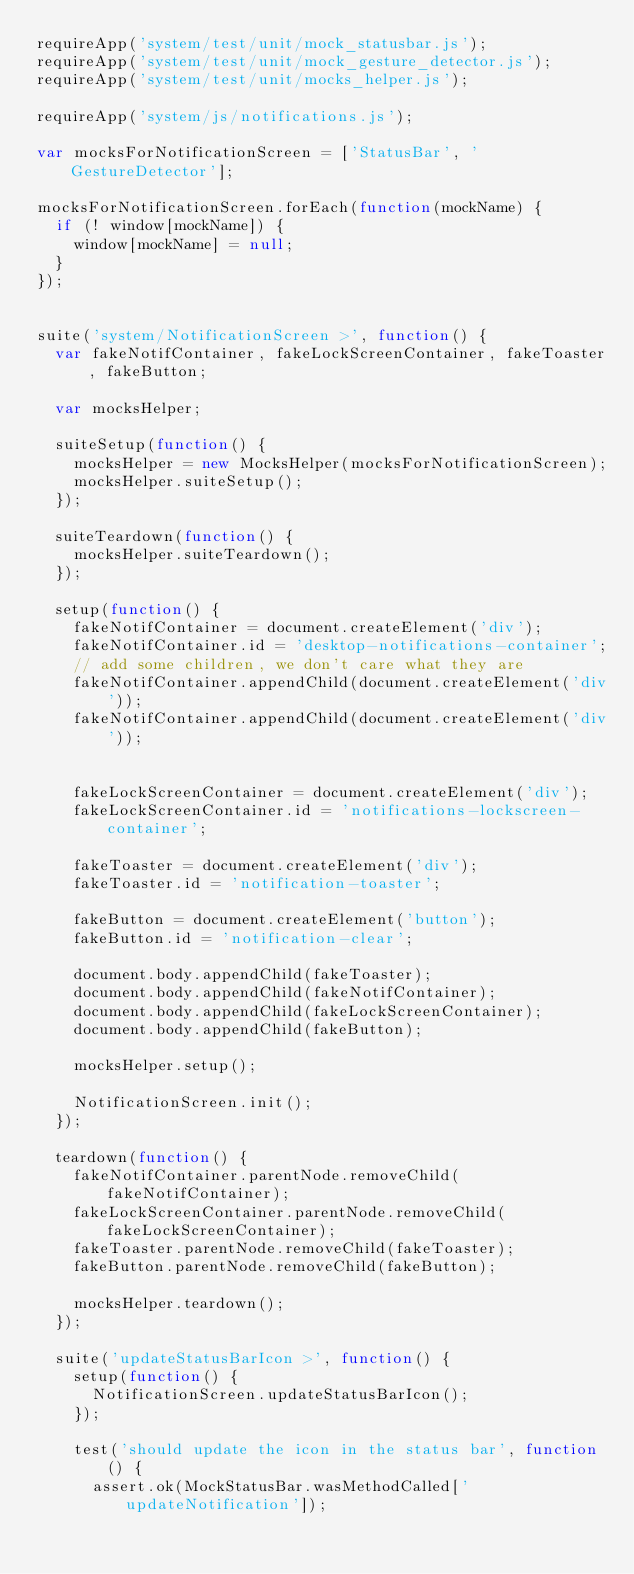<code> <loc_0><loc_0><loc_500><loc_500><_JavaScript_>requireApp('system/test/unit/mock_statusbar.js');
requireApp('system/test/unit/mock_gesture_detector.js');
requireApp('system/test/unit/mocks_helper.js');

requireApp('system/js/notifications.js');

var mocksForNotificationScreen = ['StatusBar', 'GestureDetector'];

mocksForNotificationScreen.forEach(function(mockName) {
  if (! window[mockName]) {
    window[mockName] = null;
  }
});


suite('system/NotificationScreen >', function() {
  var fakeNotifContainer, fakeLockScreenContainer, fakeToaster, fakeButton;

  var mocksHelper;

  suiteSetup(function() {
    mocksHelper = new MocksHelper(mocksForNotificationScreen);
    mocksHelper.suiteSetup();
  });

  suiteTeardown(function() {
    mocksHelper.suiteTeardown();
  });

  setup(function() {
    fakeNotifContainer = document.createElement('div');
    fakeNotifContainer.id = 'desktop-notifications-container';
    // add some children, we don't care what they are
    fakeNotifContainer.appendChild(document.createElement('div'));
    fakeNotifContainer.appendChild(document.createElement('div'));


    fakeLockScreenContainer = document.createElement('div');
    fakeLockScreenContainer.id = 'notifications-lockscreen-container';

    fakeToaster = document.createElement('div');
    fakeToaster.id = 'notification-toaster';

    fakeButton = document.createElement('button');
    fakeButton.id = 'notification-clear';

    document.body.appendChild(fakeToaster);
    document.body.appendChild(fakeNotifContainer);
    document.body.appendChild(fakeLockScreenContainer);
    document.body.appendChild(fakeButton);

    mocksHelper.setup();

    NotificationScreen.init();
  });

  teardown(function() {
    fakeNotifContainer.parentNode.removeChild(fakeNotifContainer);
    fakeLockScreenContainer.parentNode.removeChild(fakeLockScreenContainer);
    fakeToaster.parentNode.removeChild(fakeToaster);
    fakeButton.parentNode.removeChild(fakeButton);

    mocksHelper.teardown();
  });

  suite('updateStatusBarIcon >', function() {
    setup(function() {
      NotificationScreen.updateStatusBarIcon();
    });

    test('should update the icon in the status bar', function() {
      assert.ok(MockStatusBar.wasMethodCalled['updateNotification']);</code> 